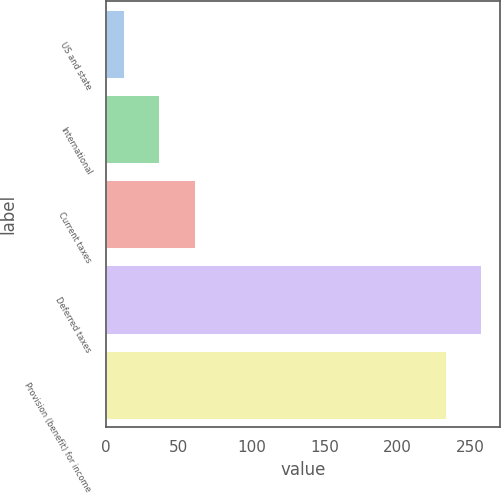<chart> <loc_0><loc_0><loc_500><loc_500><bar_chart><fcel>US and state<fcel>International<fcel>Current taxes<fcel>Deferred taxes<fcel>Provision (benefit) for income<nl><fcel>12<fcel>36.5<fcel>61<fcel>257.5<fcel>233<nl></chart> 